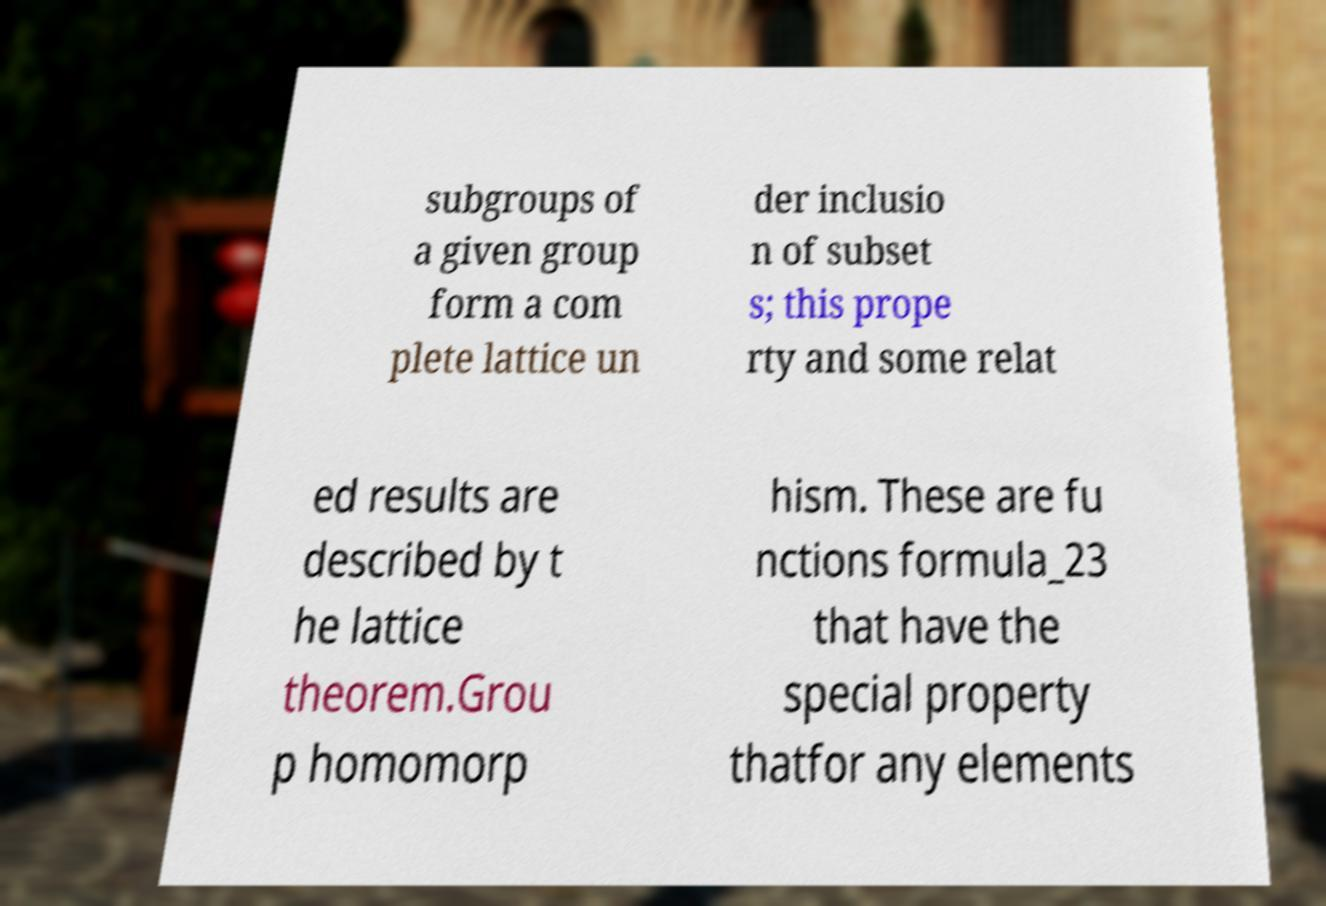I need the written content from this picture converted into text. Can you do that? subgroups of a given group form a com plete lattice un der inclusio n of subset s; this prope rty and some relat ed results are described by t he lattice theorem.Grou p homomorp hism. These are fu nctions formula_23 that have the special property thatfor any elements 